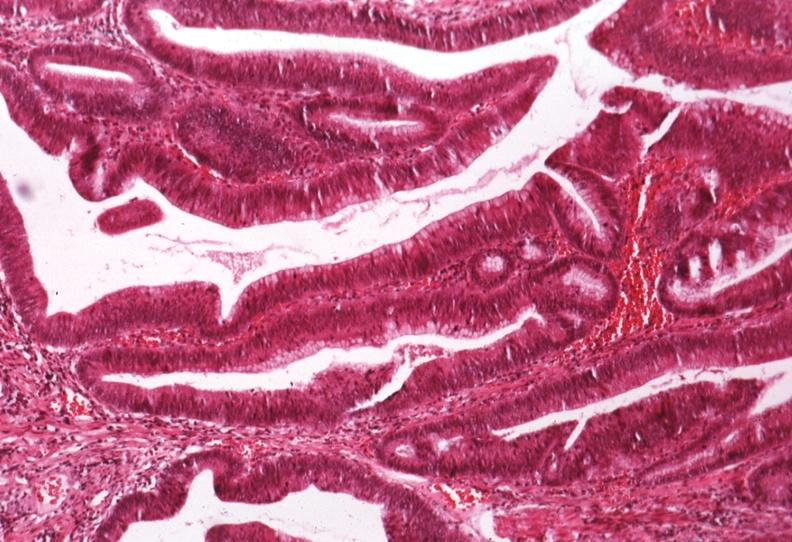s aldehyde fuscin present?
Answer the question using a single word or phrase. No 